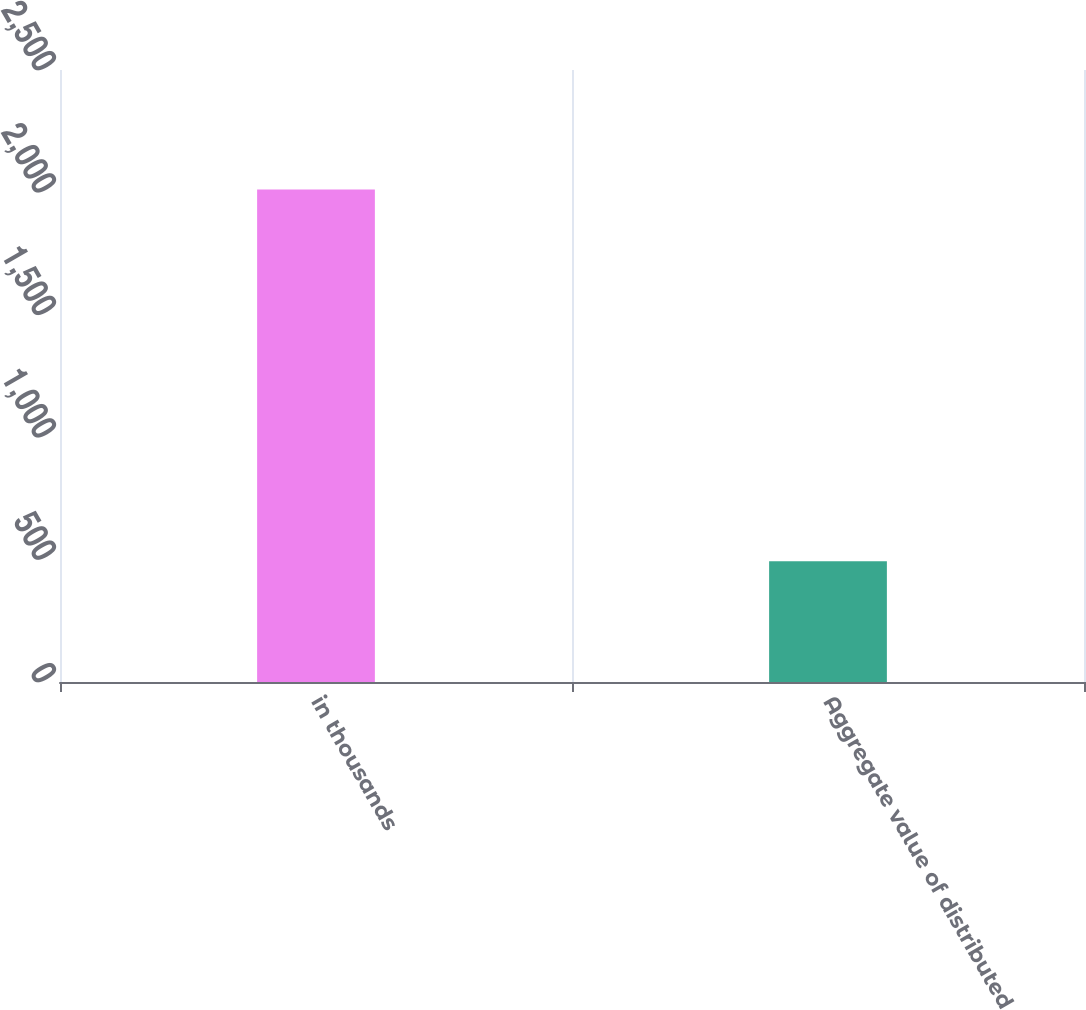Convert chart to OTSL. <chart><loc_0><loc_0><loc_500><loc_500><bar_chart><fcel>in thousands<fcel>Aggregate value of distributed<nl><fcel>2012<fcel>493<nl></chart> 